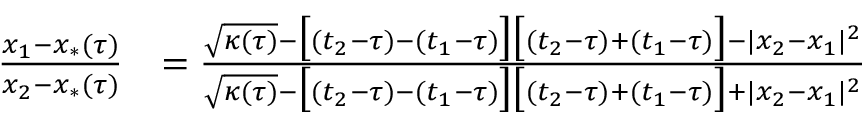<formula> <loc_0><loc_0><loc_500><loc_500>\begin{array} { r l } { \frac { x _ { 1 } - x _ { * } ( \tau ) } { x _ { 2 } - x _ { * } ( \tau ) } } & { = \frac { \sqrt { \kappa ( \tau ) } - \left [ ( t _ { 2 } - \tau ) - ( t _ { 1 } - \tau ) \right ] \left [ ( t _ { 2 } - \tau ) + ( t _ { 1 } - \tau ) \right ] - | x _ { 2 } - x _ { 1 } | ^ { 2 } } { \sqrt { \kappa ( \tau ) } - \left [ ( t _ { 2 } - \tau ) - ( t _ { 1 } - \tau ) \right ] \left [ ( t _ { 2 } - \tau ) + ( t _ { 1 } - \tau ) \right ] + | x _ { 2 } - x _ { 1 } | ^ { 2 } } } \end{array}</formula> 